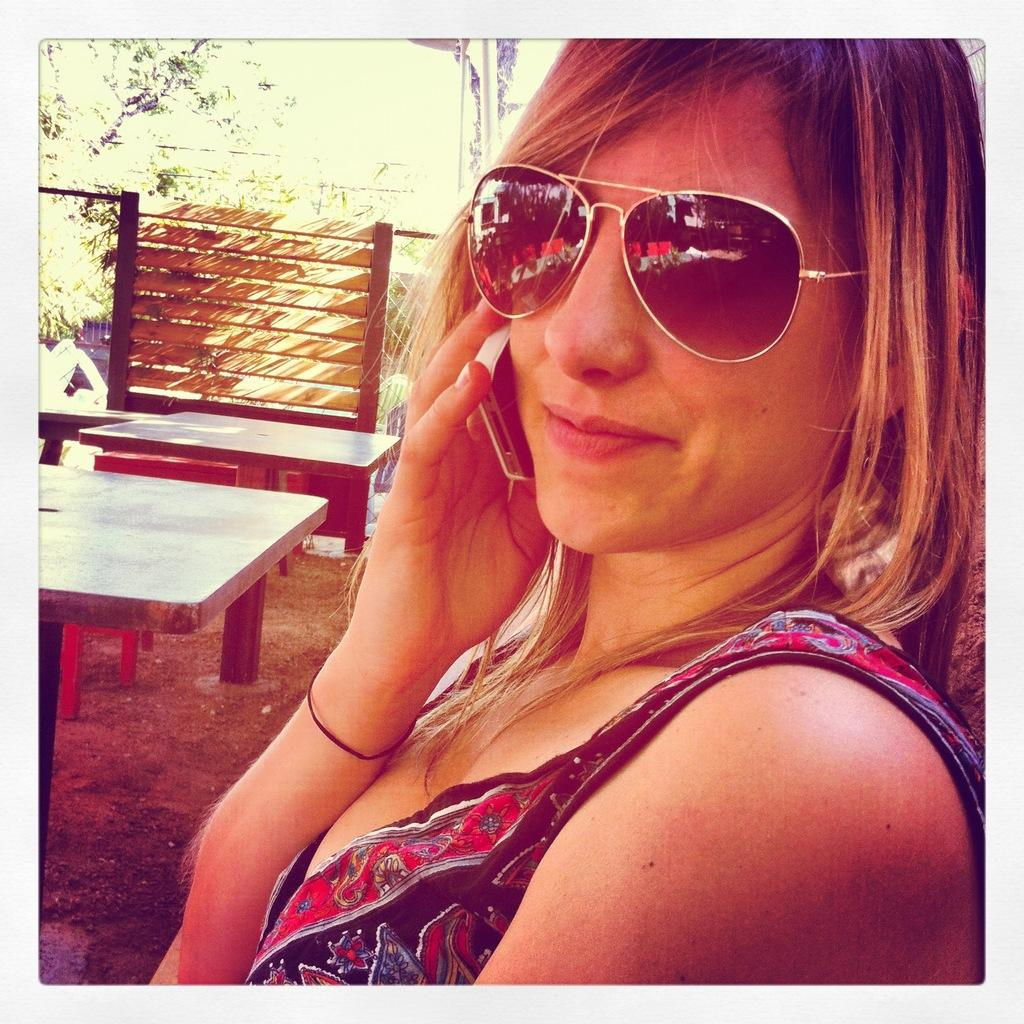Who is the main subject in the image? There is a woman in the image. What is the woman doing in the image? The woman is holding a phone near her ear. Can you describe the woman's appearance? The woman is wearing shades and smiling. What can be seen in the background of the image? There are tables and a fence in the background of the image. What type of plastic is covering the phone in the image? There is no plastic covering the phone in the image; the woman is simply holding it near her ear. 